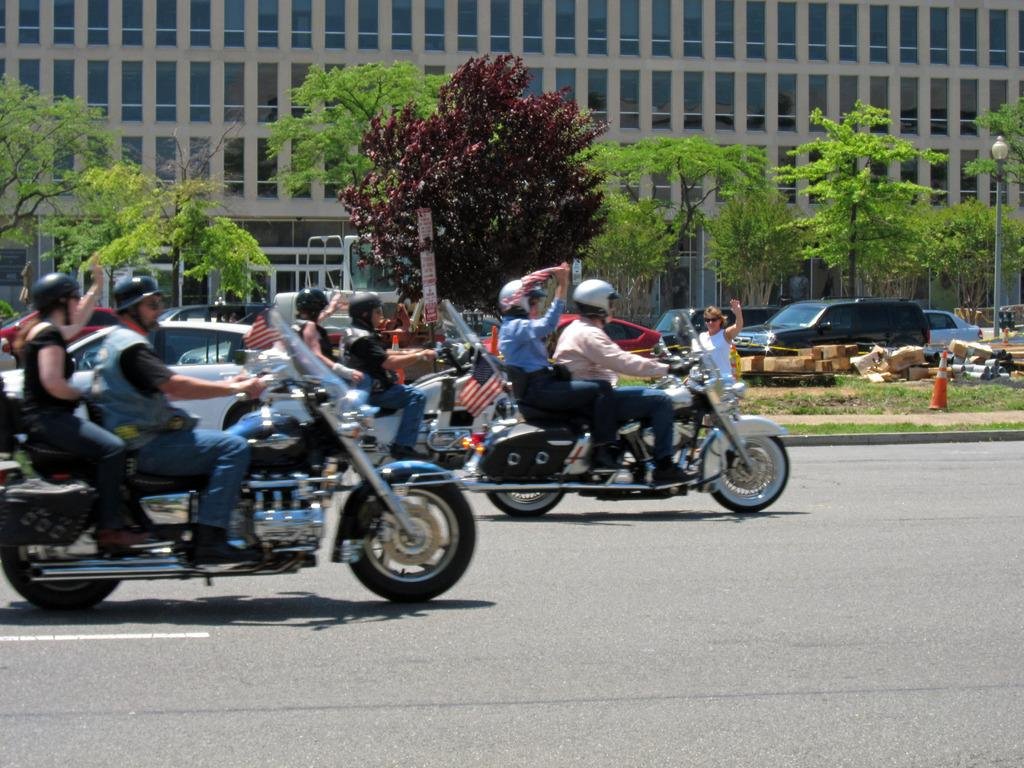What are the people in the image doing? The people in the image are riding vehicles on the road. What can be seen in the background of the image? There is a building, trees, a pole, and vehicles in the background. What type of nail is being used to power the vehicles in the image? There is no nail present in the image, and vehicles are not powered by nails. 